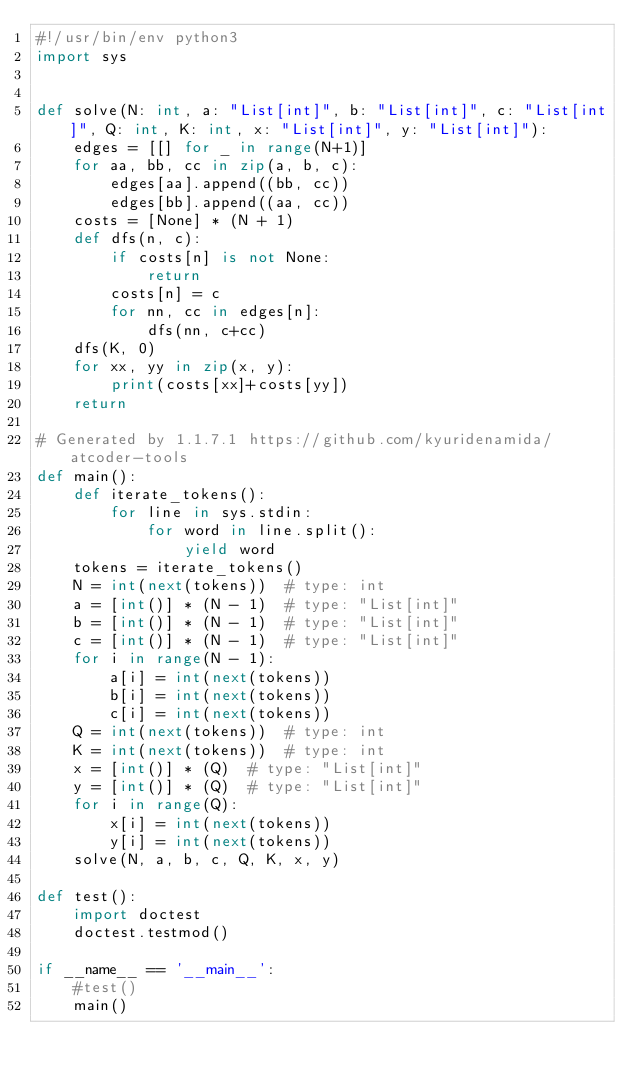Convert code to text. <code><loc_0><loc_0><loc_500><loc_500><_Python_>#!/usr/bin/env python3
import sys


def solve(N: int, a: "List[int]", b: "List[int]", c: "List[int]", Q: int, K: int, x: "List[int]", y: "List[int]"):
    edges = [[] for _ in range(N+1)]
    for aa, bb, cc in zip(a, b, c):
        edges[aa].append((bb, cc))
        edges[bb].append((aa, cc))
    costs = [None] * (N + 1)
    def dfs(n, c):
        if costs[n] is not None:
            return
        costs[n] = c
        for nn, cc in edges[n]:
            dfs(nn, c+cc)
    dfs(K, 0)
    for xx, yy in zip(x, y):
        print(costs[xx]+costs[yy])
    return

# Generated by 1.1.7.1 https://github.com/kyuridenamida/atcoder-tools
def main():
    def iterate_tokens():
        for line in sys.stdin:
            for word in line.split():
                yield word
    tokens = iterate_tokens()
    N = int(next(tokens))  # type: int
    a = [int()] * (N - 1)  # type: "List[int]"
    b = [int()] * (N - 1)  # type: "List[int]"
    c = [int()] * (N - 1)  # type: "List[int]"
    for i in range(N - 1):
        a[i] = int(next(tokens))
        b[i] = int(next(tokens))
        c[i] = int(next(tokens))
    Q = int(next(tokens))  # type: int
    K = int(next(tokens))  # type: int
    x = [int()] * (Q)  # type: "List[int]"
    y = [int()] * (Q)  # type: "List[int]"
    for i in range(Q):
        x[i] = int(next(tokens))
        y[i] = int(next(tokens))
    solve(N, a, b, c, Q, K, x, y)

def test():
    import doctest
    doctest.testmod()

if __name__ == '__main__':
    #test()
    main()
</code> 